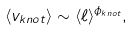Convert formula to latex. <formula><loc_0><loc_0><loc_500><loc_500>\langle v _ { k n o t } \rangle \sim \langle \ell \rangle ^ { \phi _ { k n o t } } ,</formula> 